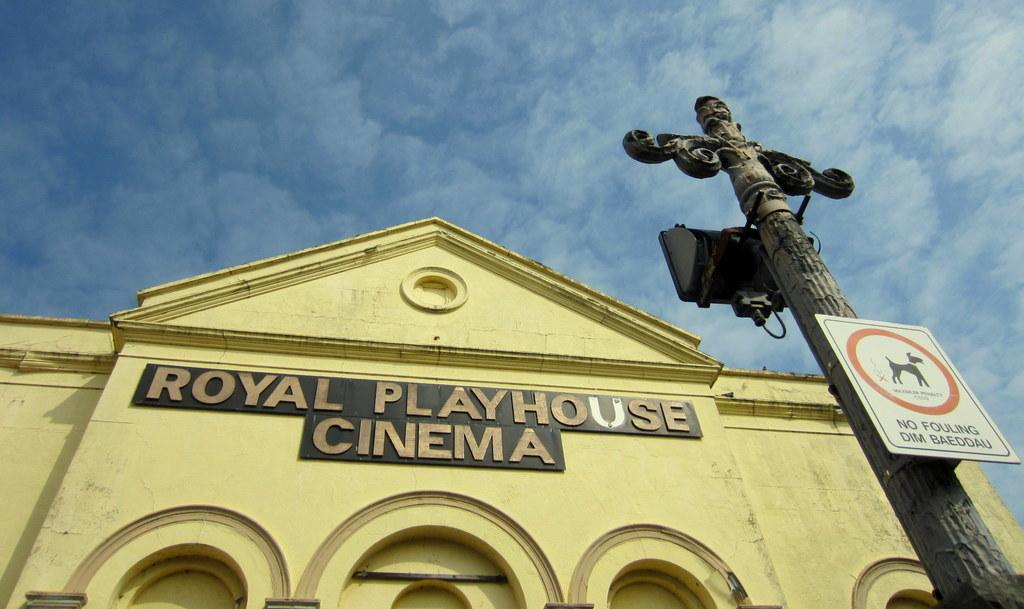<image>
Share a concise interpretation of the image provided. a building with a sign on it that says 'royal playhouse cinema' 